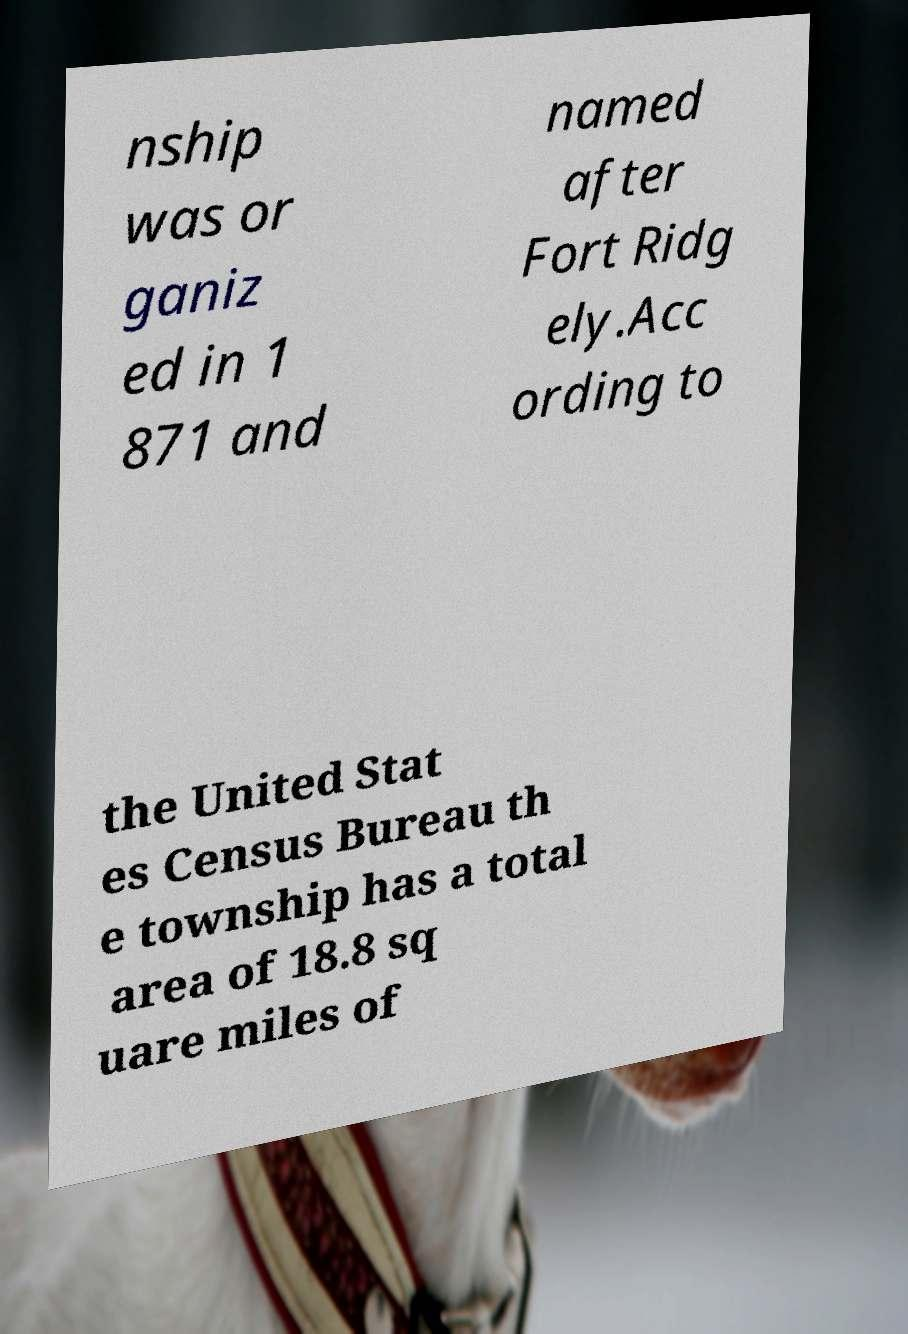What messages or text are displayed in this image? I need them in a readable, typed format. nship was or ganiz ed in 1 871 and named after Fort Ridg ely.Acc ording to the United Stat es Census Bureau th e township has a total area of 18.8 sq uare miles of 